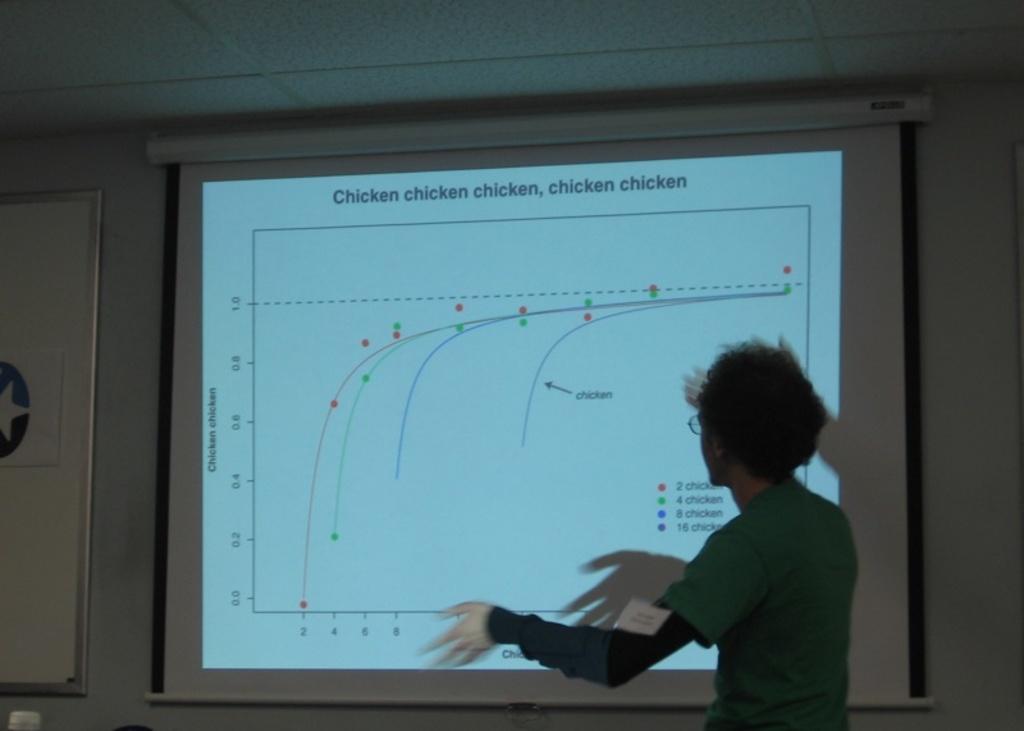What is the title of the presentation?
Provide a succinct answer. Chicken chicken chicken, chicken chicken. 